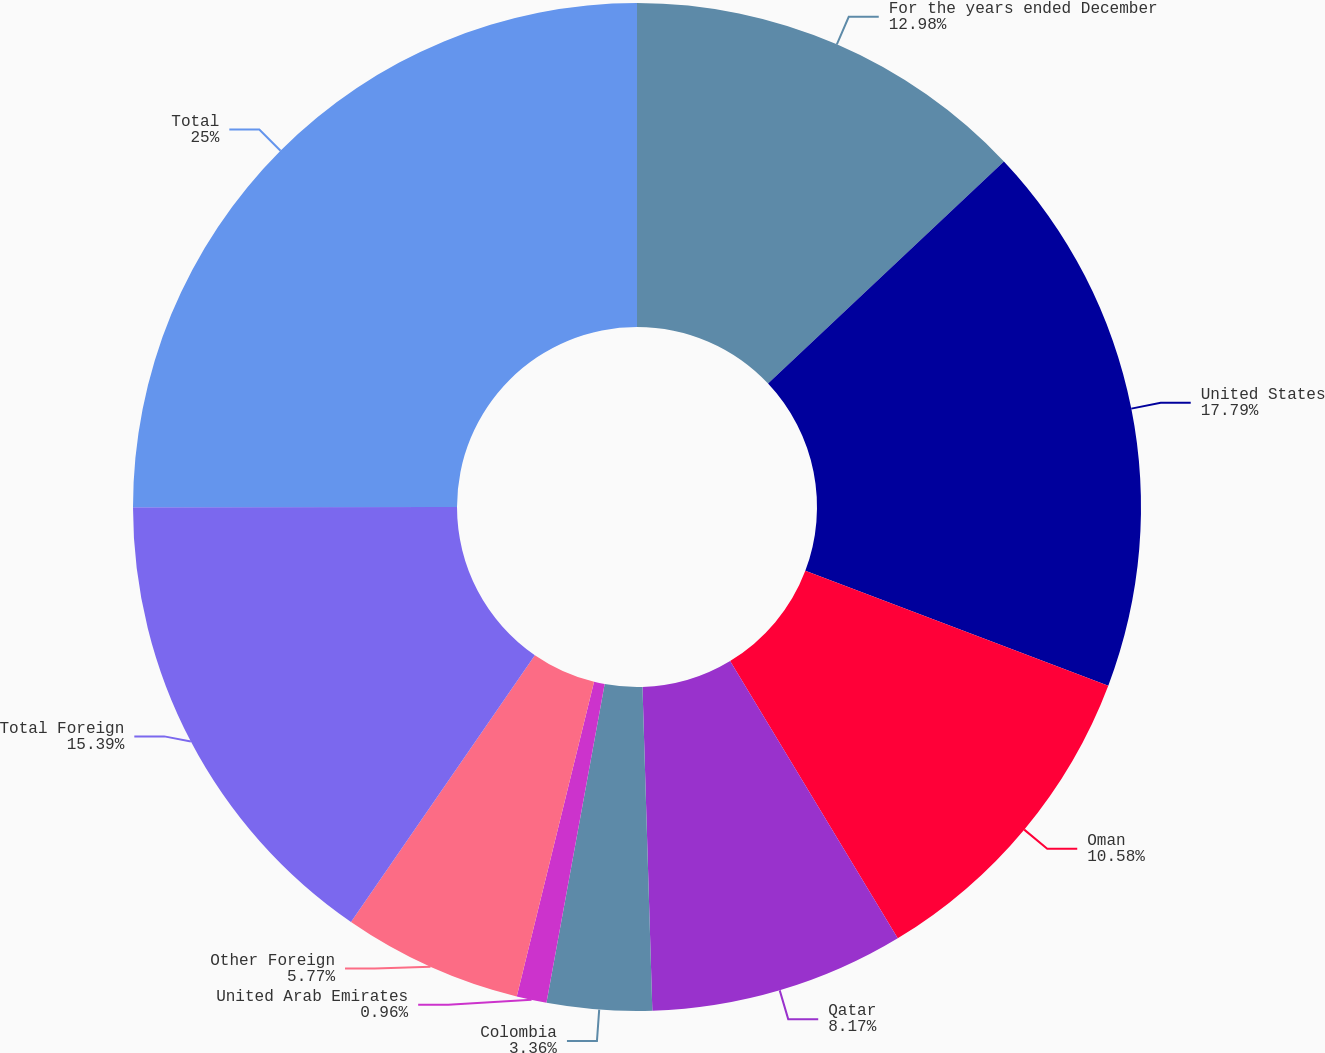<chart> <loc_0><loc_0><loc_500><loc_500><pie_chart><fcel>For the years ended December<fcel>United States<fcel>Oman<fcel>Qatar<fcel>Colombia<fcel>United Arab Emirates<fcel>Other Foreign<fcel>Total Foreign<fcel>Total<nl><fcel>12.98%<fcel>17.79%<fcel>10.58%<fcel>8.17%<fcel>3.36%<fcel>0.96%<fcel>5.77%<fcel>15.39%<fcel>25.01%<nl></chart> 